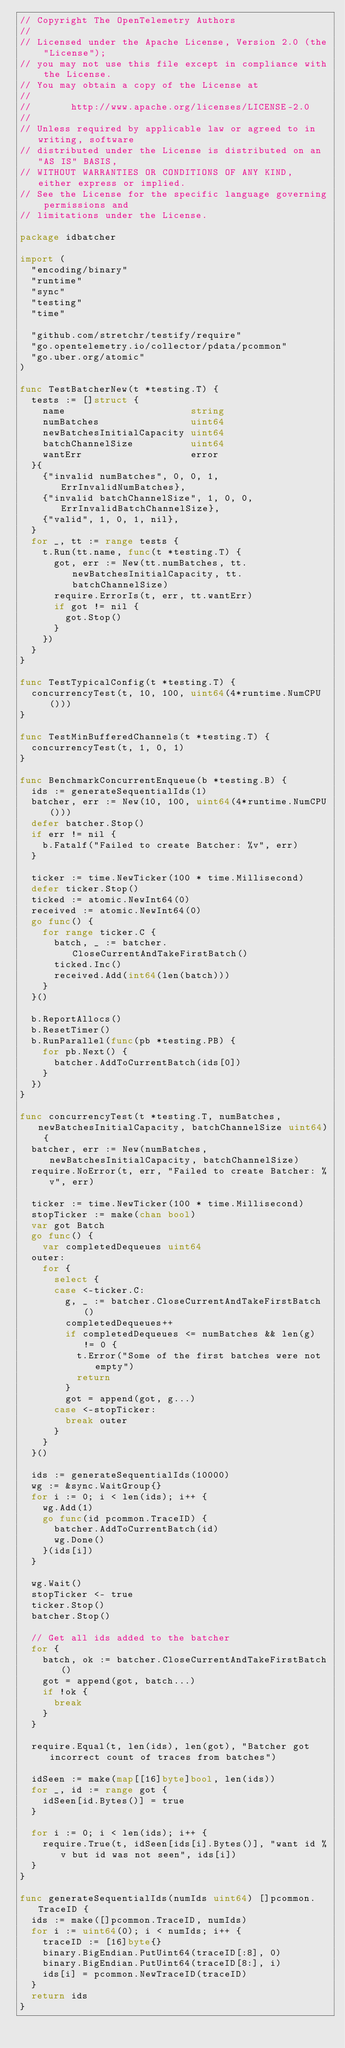<code> <loc_0><loc_0><loc_500><loc_500><_Go_>// Copyright The OpenTelemetry Authors
//
// Licensed under the Apache License, Version 2.0 (the "License");
// you may not use this file except in compliance with the License.
// You may obtain a copy of the License at
//
//       http://www.apache.org/licenses/LICENSE-2.0
//
// Unless required by applicable law or agreed to in writing, software
// distributed under the License is distributed on an "AS IS" BASIS,
// WITHOUT WARRANTIES OR CONDITIONS OF ANY KIND, either express or implied.
// See the License for the specific language governing permissions and
// limitations under the License.

package idbatcher

import (
	"encoding/binary"
	"runtime"
	"sync"
	"testing"
	"time"

	"github.com/stretchr/testify/require"
	"go.opentelemetry.io/collector/pdata/pcommon"
	"go.uber.org/atomic"
)

func TestBatcherNew(t *testing.T) {
	tests := []struct {
		name                      string
		numBatches                uint64
		newBatchesInitialCapacity uint64
		batchChannelSize          uint64
		wantErr                   error
	}{
		{"invalid numBatches", 0, 0, 1, ErrInvalidNumBatches},
		{"invalid batchChannelSize", 1, 0, 0, ErrInvalidBatchChannelSize},
		{"valid", 1, 0, 1, nil},
	}
	for _, tt := range tests {
		t.Run(tt.name, func(t *testing.T) {
			got, err := New(tt.numBatches, tt.newBatchesInitialCapacity, tt.batchChannelSize)
			require.ErrorIs(t, err, tt.wantErr)
			if got != nil {
				got.Stop()
			}
		})
	}
}

func TestTypicalConfig(t *testing.T) {
	concurrencyTest(t, 10, 100, uint64(4*runtime.NumCPU()))
}

func TestMinBufferedChannels(t *testing.T) {
	concurrencyTest(t, 1, 0, 1)
}

func BenchmarkConcurrentEnqueue(b *testing.B) {
	ids := generateSequentialIds(1)
	batcher, err := New(10, 100, uint64(4*runtime.NumCPU()))
	defer batcher.Stop()
	if err != nil {
		b.Fatalf("Failed to create Batcher: %v", err)
	}

	ticker := time.NewTicker(100 * time.Millisecond)
	defer ticker.Stop()
	ticked := atomic.NewInt64(0)
	received := atomic.NewInt64(0)
	go func() {
		for range ticker.C {
			batch, _ := batcher.CloseCurrentAndTakeFirstBatch()
			ticked.Inc()
			received.Add(int64(len(batch)))
		}
	}()

	b.ReportAllocs()
	b.ResetTimer()
	b.RunParallel(func(pb *testing.PB) {
		for pb.Next() {
			batcher.AddToCurrentBatch(ids[0])
		}
	})
}

func concurrencyTest(t *testing.T, numBatches, newBatchesInitialCapacity, batchChannelSize uint64) {
	batcher, err := New(numBatches, newBatchesInitialCapacity, batchChannelSize)
	require.NoError(t, err, "Failed to create Batcher: %v", err)

	ticker := time.NewTicker(100 * time.Millisecond)
	stopTicker := make(chan bool)
	var got Batch
	go func() {
		var completedDequeues uint64
	outer:
		for {
			select {
			case <-ticker.C:
				g, _ := batcher.CloseCurrentAndTakeFirstBatch()
				completedDequeues++
				if completedDequeues <= numBatches && len(g) != 0 {
					t.Error("Some of the first batches were not empty")
					return
				}
				got = append(got, g...)
			case <-stopTicker:
				break outer
			}
		}
	}()

	ids := generateSequentialIds(10000)
	wg := &sync.WaitGroup{}
	for i := 0; i < len(ids); i++ {
		wg.Add(1)
		go func(id pcommon.TraceID) {
			batcher.AddToCurrentBatch(id)
			wg.Done()
		}(ids[i])
	}

	wg.Wait()
	stopTicker <- true
	ticker.Stop()
	batcher.Stop()

	// Get all ids added to the batcher
	for {
		batch, ok := batcher.CloseCurrentAndTakeFirstBatch()
		got = append(got, batch...)
		if !ok {
			break
		}
	}

	require.Equal(t, len(ids), len(got), "Batcher got incorrect count of traces from batches")

	idSeen := make(map[[16]byte]bool, len(ids))
	for _, id := range got {
		idSeen[id.Bytes()] = true
	}

	for i := 0; i < len(ids); i++ {
		require.True(t, idSeen[ids[i].Bytes()], "want id %v but id was not seen", ids[i])
	}
}

func generateSequentialIds(numIds uint64) []pcommon.TraceID {
	ids := make([]pcommon.TraceID, numIds)
	for i := uint64(0); i < numIds; i++ {
		traceID := [16]byte{}
		binary.BigEndian.PutUint64(traceID[:8], 0)
		binary.BigEndian.PutUint64(traceID[8:], i)
		ids[i] = pcommon.NewTraceID(traceID)
	}
	return ids
}
</code> 